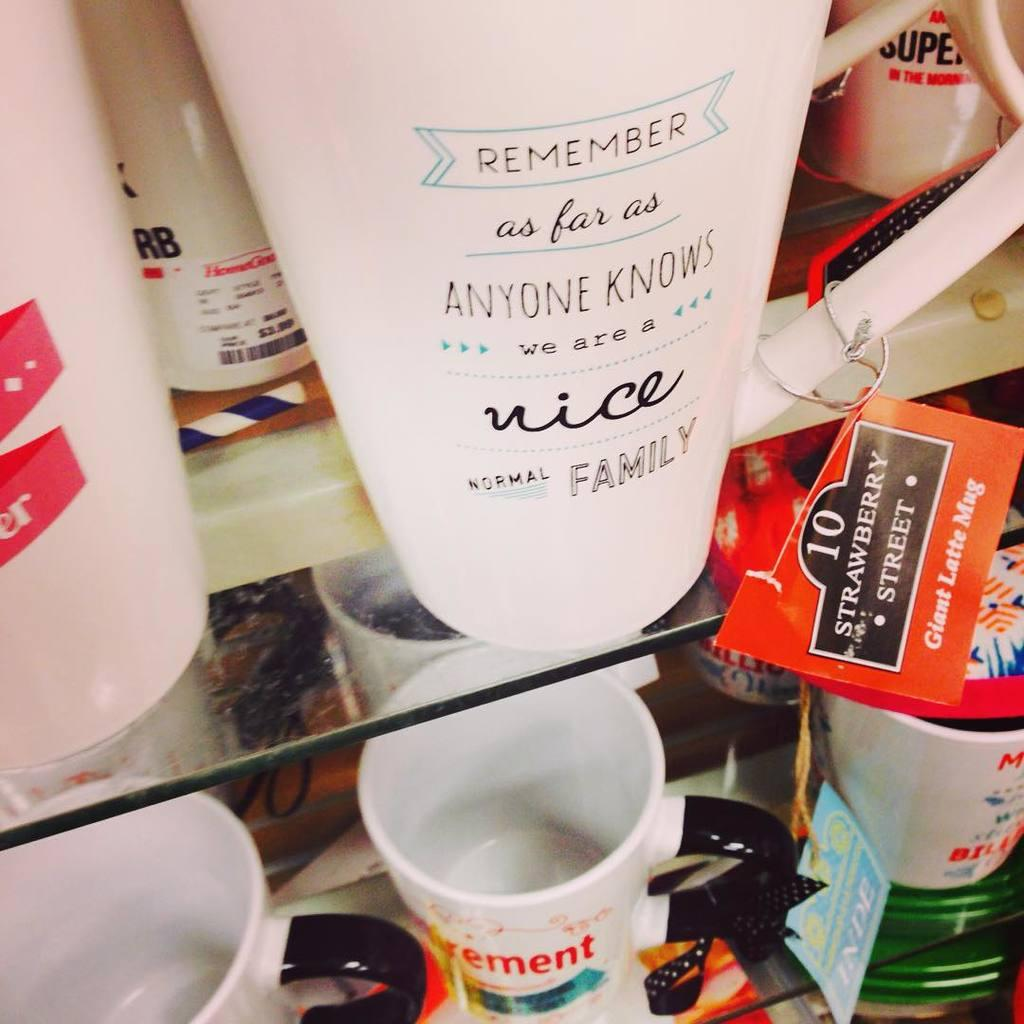What type of storage system is shown in the image? There are glass racks in the image. What items are stored on the glass racks? The glass racks contain cups. What can be seen on the cups? The cups have something written on them. Are there any additional markings or labels on the cups? Yes, there are tags on the cups. What type of beetle can be seen crawling on the glass racks in the image? There is no beetle present in the image; it only features glass racks, cups, writing, and tags. 